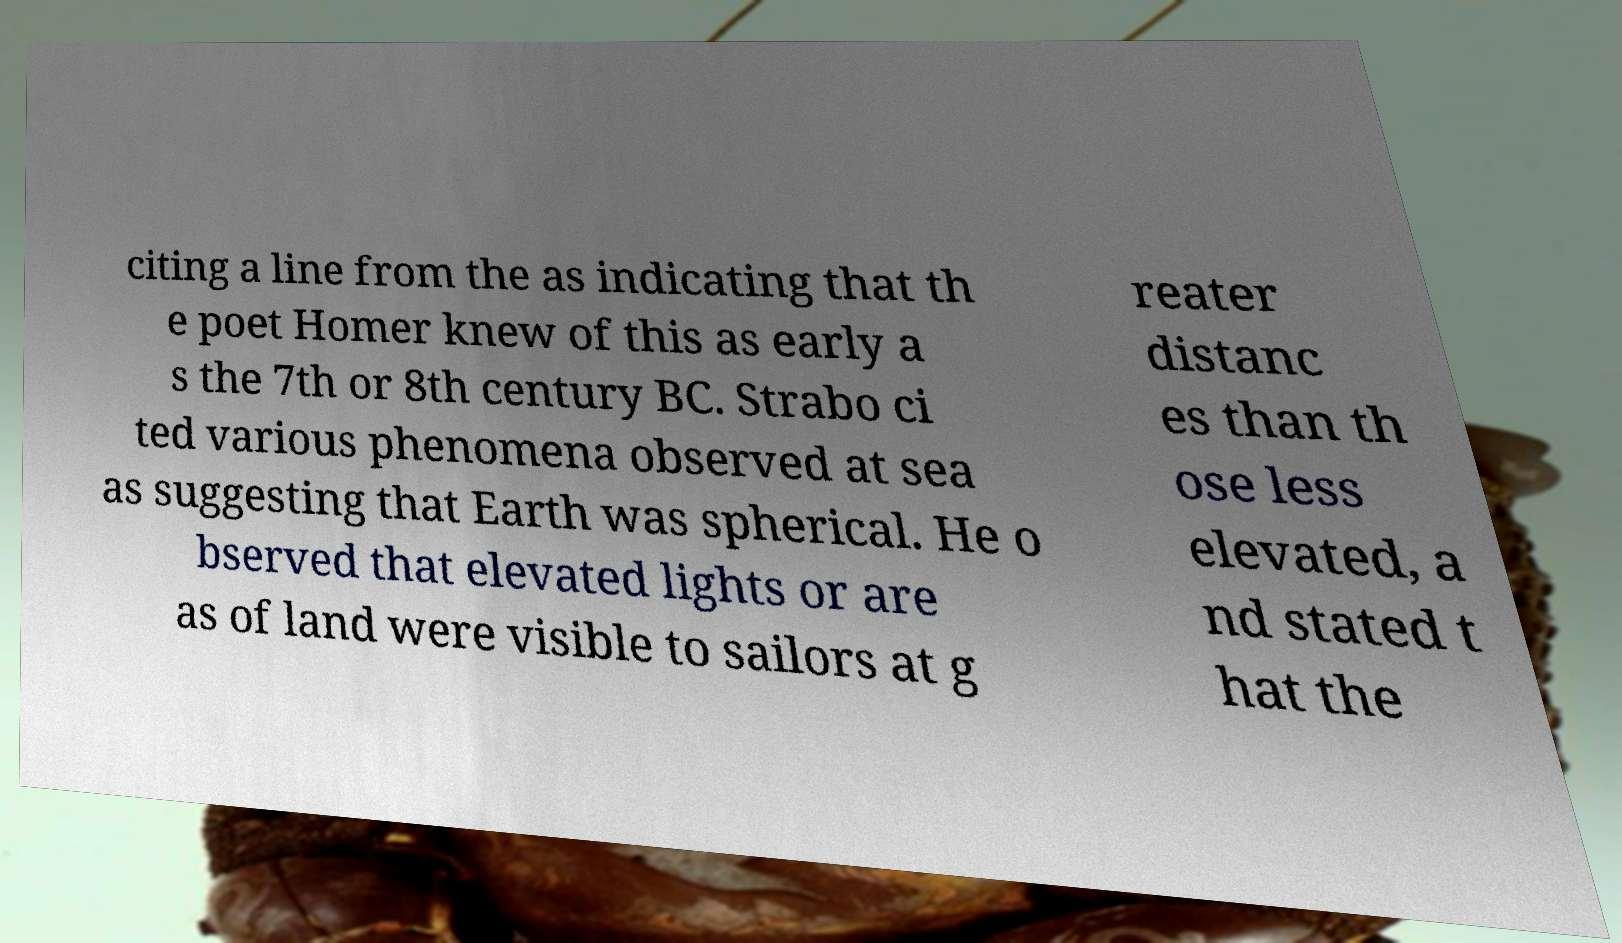Please read and relay the text visible in this image. What does it say? citing a line from the as indicating that th e poet Homer knew of this as early a s the 7th or 8th century BC. Strabo ci ted various phenomena observed at sea as suggesting that Earth was spherical. He o bserved that elevated lights or are as of land were visible to sailors at g reater distanc es than th ose less elevated, a nd stated t hat the 